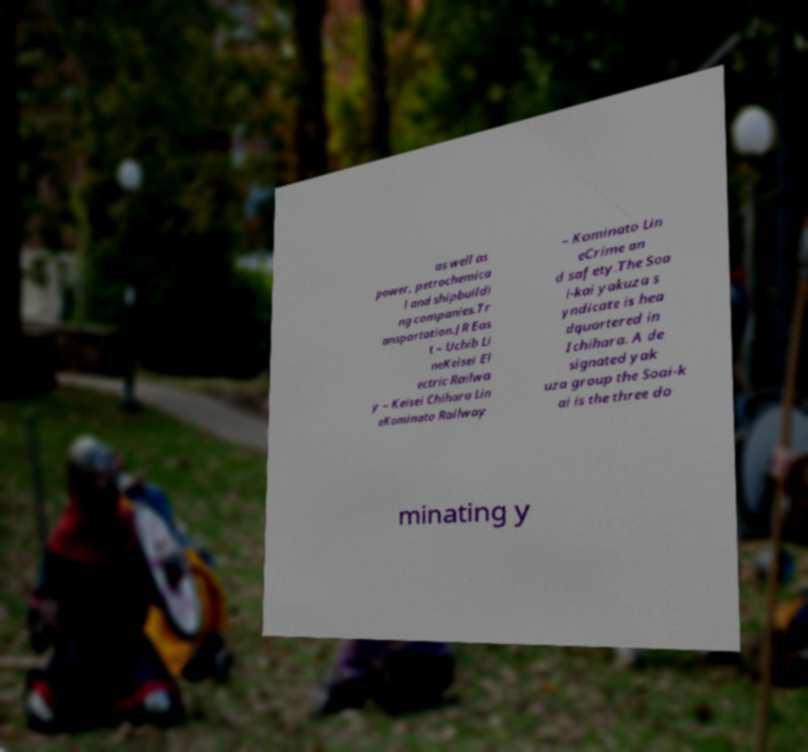Please read and relay the text visible in this image. What does it say? as well as power, petrochemica l and shipbuildi ng companies.Tr ansportation.JR Eas t – Uchib Li neKeisei El ectric Railwa y – Keisei Chihara Lin eKominato Railway – Kominato Lin eCrime an d safety.The Soa i-kai yakuza s yndicate is hea dquartered in Ichihara. A de signated yak uza group the Soai-k ai is the three do minating y 